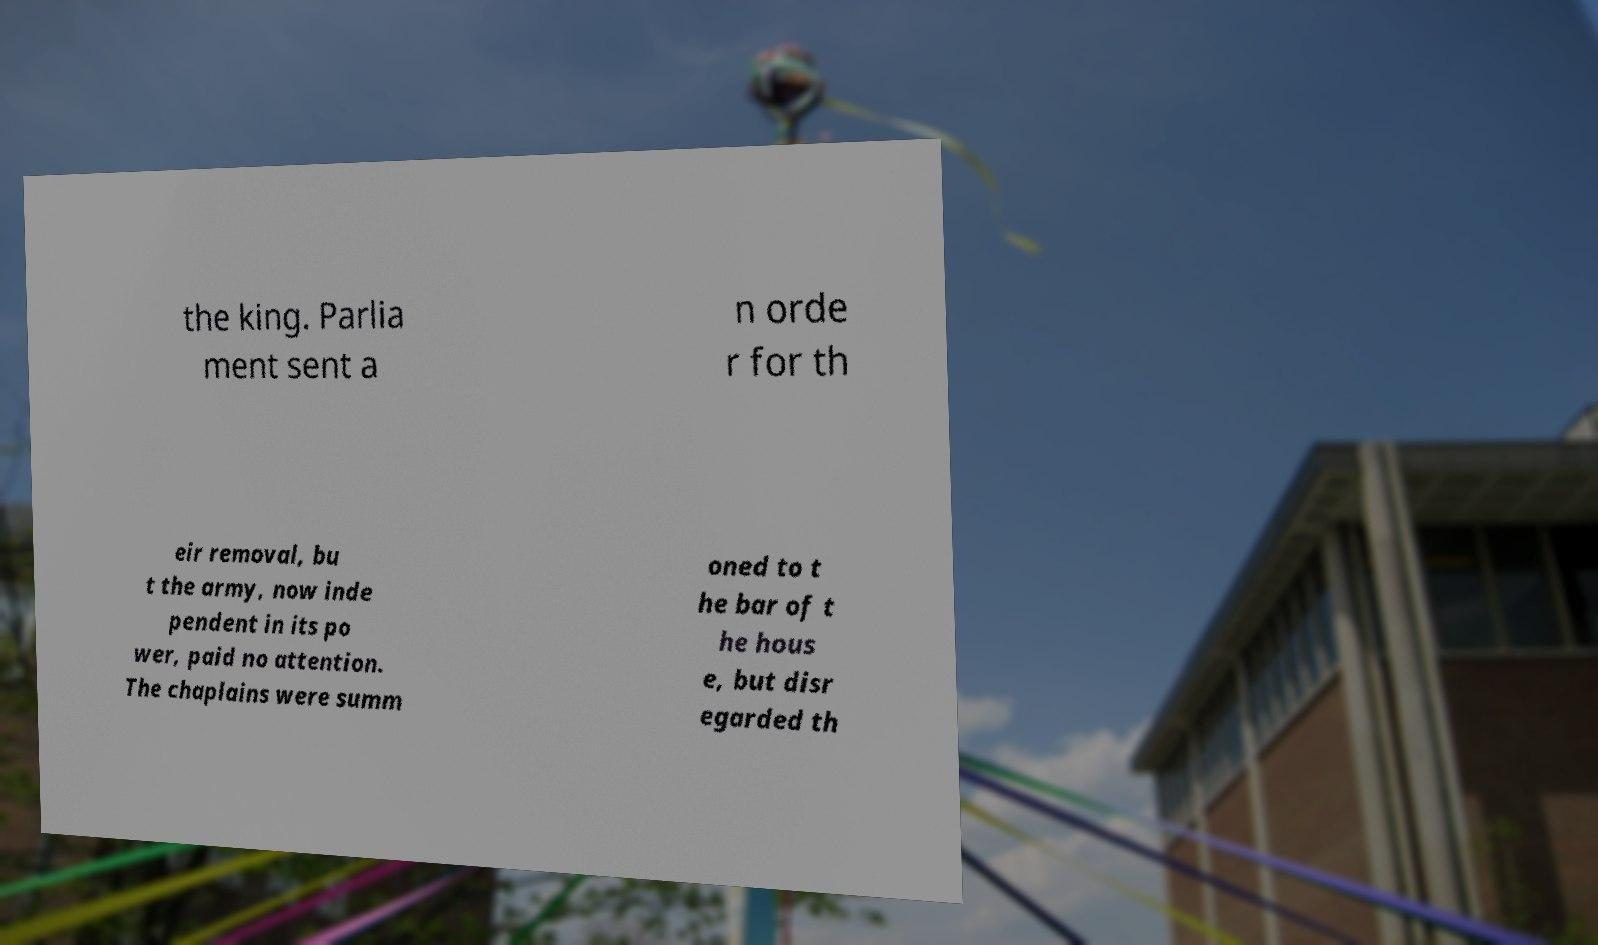For documentation purposes, I need the text within this image transcribed. Could you provide that? the king. Parlia ment sent a n orde r for th eir removal, bu t the army, now inde pendent in its po wer, paid no attention. The chaplains were summ oned to t he bar of t he hous e, but disr egarded th 